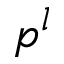Convert formula to latex. <formula><loc_0><loc_0><loc_500><loc_500>p ^ { l }</formula> 